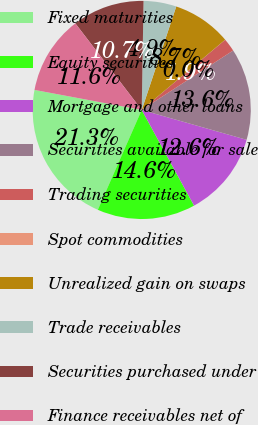Convert chart to OTSL. <chart><loc_0><loc_0><loc_500><loc_500><pie_chart><fcel>Fixed maturities<fcel>Equity securities<fcel>Mortgage and other loans<fcel>Securities available for sale<fcel>Trading securities<fcel>Spot commodities<fcel>Unrealized gain on swaps<fcel>Trade receivables<fcel>Securities purchased under<fcel>Finance receivables net of<nl><fcel>21.35%<fcel>14.56%<fcel>12.62%<fcel>13.59%<fcel>1.95%<fcel>0.01%<fcel>8.74%<fcel>4.86%<fcel>10.68%<fcel>11.65%<nl></chart> 